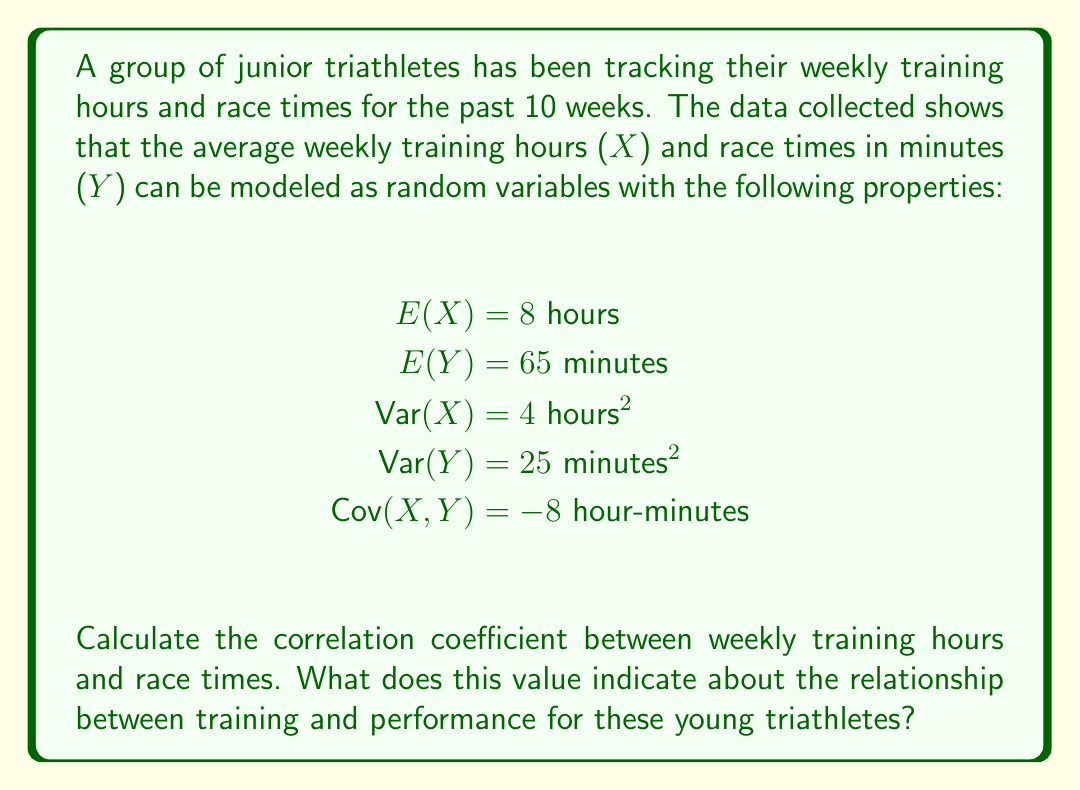Could you help me with this problem? To solve this problem, we'll follow these steps:

1) The correlation coefficient (ρ) is given by the formula:

   $$\rho = \frac{Cov(X,Y)}{\sqrt{Var(X) \cdot Var(Y)}}$$

2) We're given:
   $Cov(X,Y) = -8$ hour-minutes
   $Var(X) = 4$ hours²
   $Var(Y) = 25$ minutes²

3) Let's substitute these values into the formula:

   $$\rho = \frac{-8}{\sqrt{4 \cdot 25}}$$

4) Simplify under the square root:

   $$\rho = \frac{-8}{\sqrt{100}}$$

5) Calculate the square root:

   $$\rho = \frac{-8}{10}$$

6) Simplify the fraction:

   $$\rho = -0.8$$

7) Interpret the result:
   The correlation coefficient ranges from -1 to 1. A value of -0.8 indicates a strong negative correlation between weekly training hours and race times. This means that as training hours increase, race times tend to decrease significantly.

   For these junior triathletes, more training is strongly associated with better performance (shorter race times). This strong negative correlation suggests that their training is effective in improving their race times.
Answer: $\rho = -0.8$, indicating a strong negative correlation between training hours and race times. 